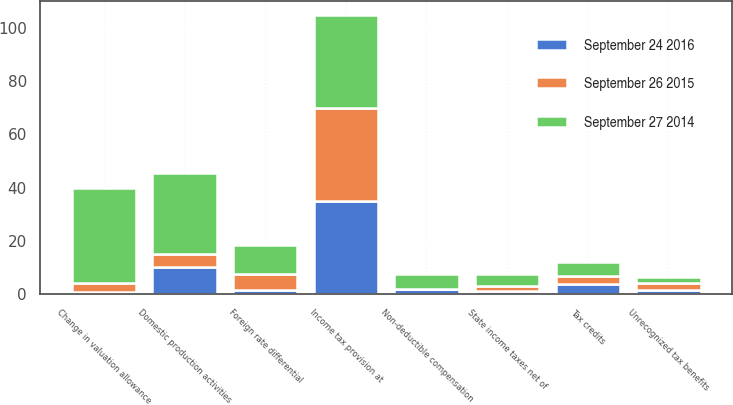Convert chart. <chart><loc_0><loc_0><loc_500><loc_500><stacked_bar_chart><ecel><fcel>Income tax provision at<fcel>Domestic production activities<fcel>State income taxes net of<fcel>Tax credits<fcel>Unrecognized tax benefits<fcel>Non-deductible compensation<fcel>Foreign rate differential<fcel>Change in valuation allowance<nl><fcel>September 26 2015<fcel>35<fcel>5<fcel>2<fcel>3.2<fcel>2.4<fcel>0.1<fcel>6.1<fcel>3.4<nl><fcel>September 24 2016<fcel>35<fcel>10.1<fcel>1.2<fcel>3.8<fcel>1.8<fcel>1.9<fcel>1.6<fcel>1<nl><fcel>September 27 2014<fcel>35<fcel>30.6<fcel>4.3<fcel>5.2<fcel>2.5<fcel>5.5<fcel>10.7<fcel>35.4<nl></chart> 